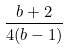<formula> <loc_0><loc_0><loc_500><loc_500>\frac { b + 2 } { 4 ( b - 1 ) }</formula> 